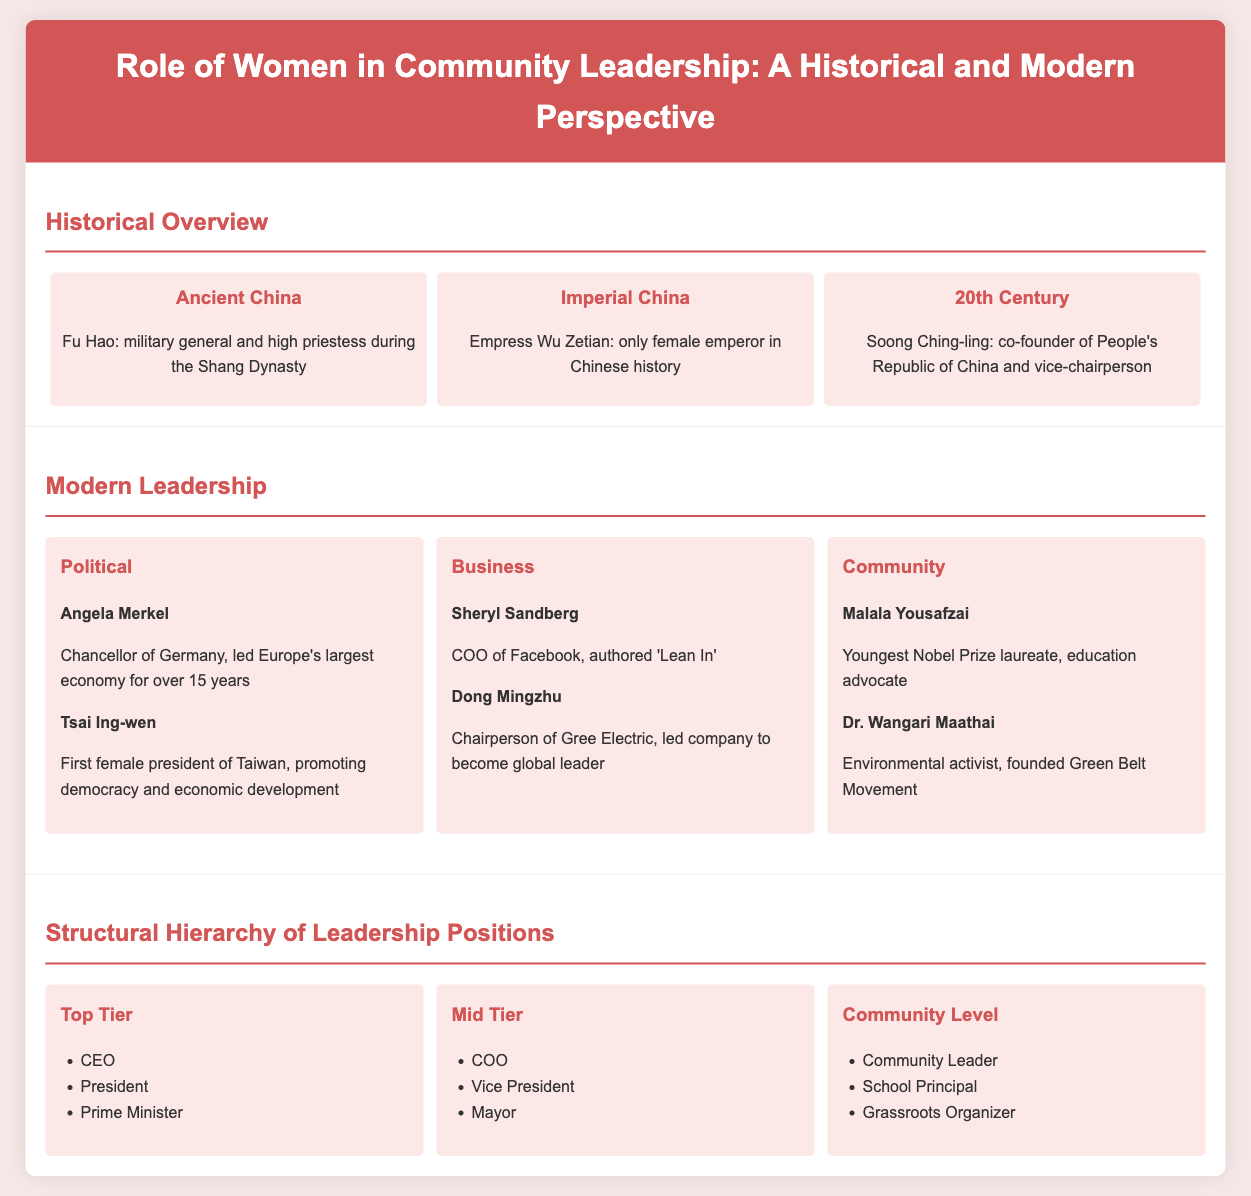What is the name of the only female emperor in Chinese history? The document states Empress Wu Zetian as the only female emperor in Chinese history during the Imperial China section.
Answer: Wu Zetian Who is the youngest Nobel Prize laureate mentioned in the document? The document identifies Malala Yousafzai as the youngest Nobel Prize laureate in the Modern Leadership section.
Answer: Malala Yousafzai What role did Fu Hao hold during the Shang Dynasty? According to the document, Fu Hao was a military general and high priestess during the Shang Dynasty in the Historical Overview.
Answer: Military general and high priestess Which tier in the structural hierarchy includes the title of Mayor? The Mayor is listed under the Mid Tier section of the Structural Hierarchy of Leadership Positions.
Answer: Mid Tier How long did Angela Merkel lead Germany? The document states Angela Merkel led Europe's largest economy for over 15 years in the Modern Leadership section.
Answer: Over 15 years What position did Soong Ching-ling hold in the People's Republic of China? The document states she was the co-founder and vice-chairperson of the People's Republic of China in the Historical Overview.
Answer: Vice-chairperson What type of leadership does Dong Mingzhu exemplify? Dong Mingzhu is highlighted in the Business aspect of Modern Leadership, showing her role in business leadership.
Answer: Business What is the focus of the Green Belt Movement founded by Dr. Wangari Maathai? The document describes Dr. Wangari Maathai as an environmental activist who founded the Green Belt Movement.
Answer: Environmental activism 